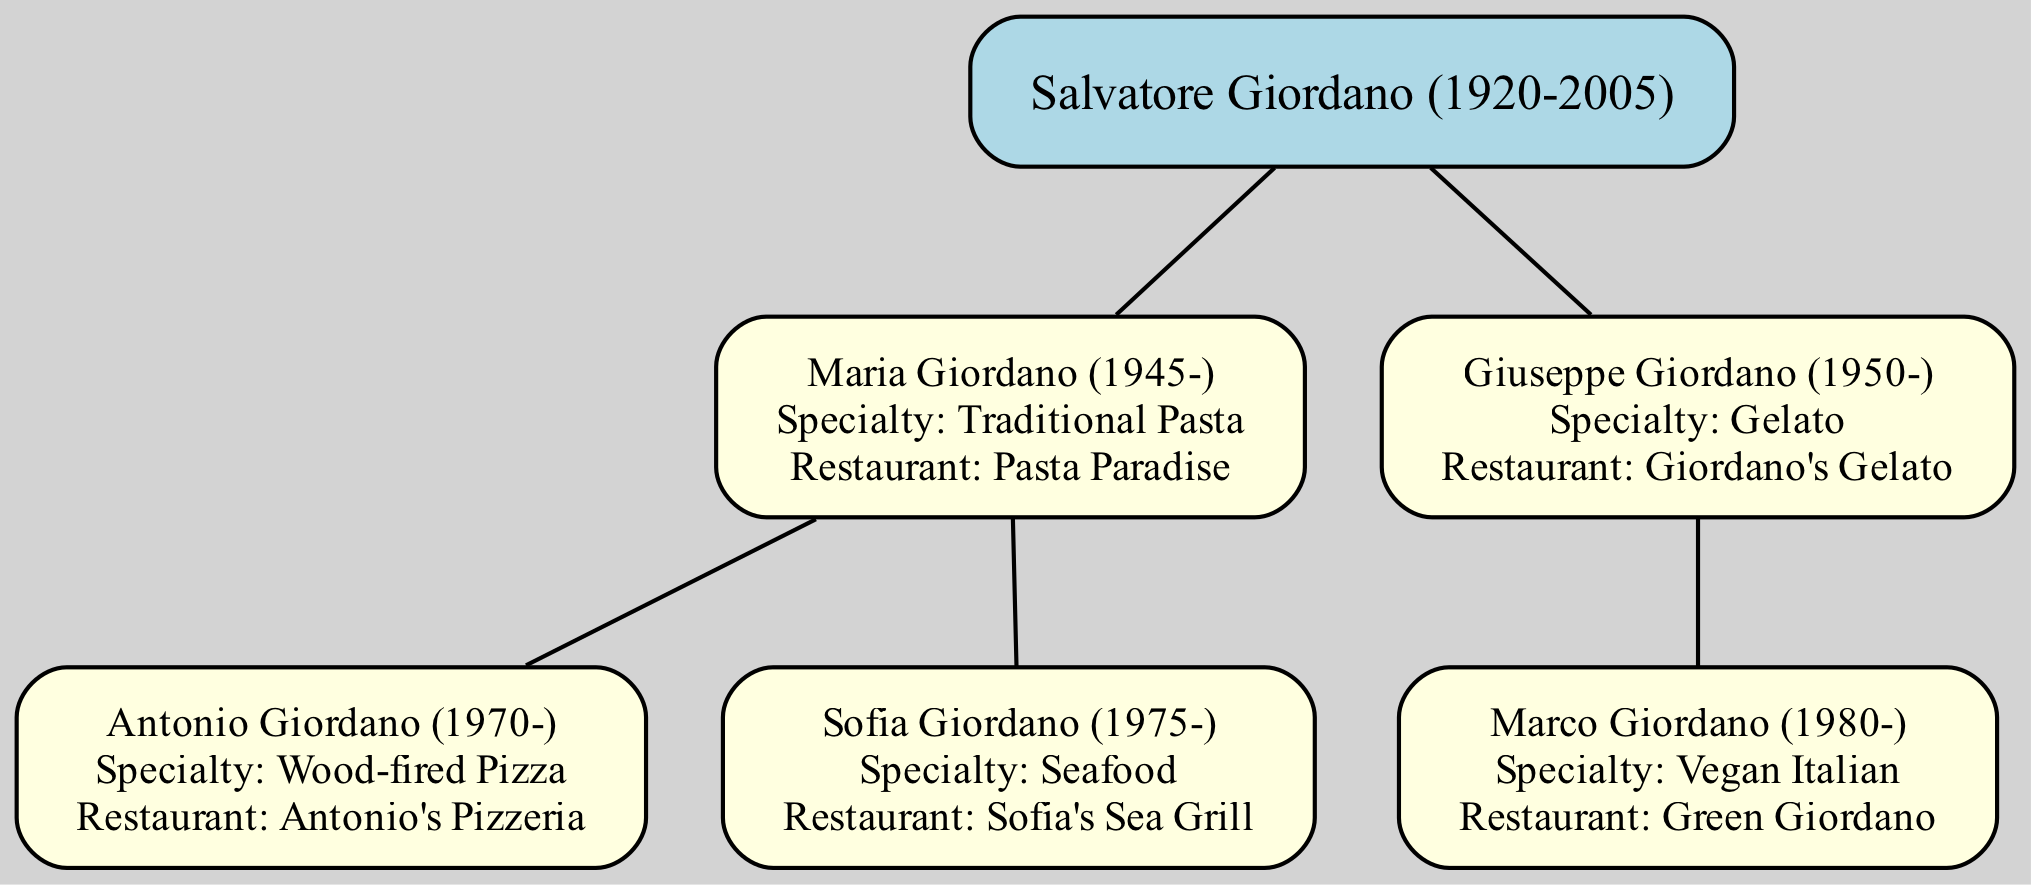What is the name of the root person in the family tree? The root person is Salvatore Giordano, who is the founding member of this family tree of restaurant owners.
Answer: Salvatore Giordano How many children does Maria Giordano have? Maria Giordano has two children: Antonio Giordano and Sofia Giordano, as indicated by her lineage in the diagram.
Answer: 2 What specialty is associated with Giuseppe Giordano? Giuseppe Giordano is known for his specialty in Gelato, which is explicitly stated in the diagram under his name.
Answer: Gelato Which restaurant does Sofia Giordano own? Sofia Giordano owns Sofia's Sea Grill, as specified next to her name in the diagram.
Answer: Sofia's Sea Grill Who is the only child of Giuseppe Giordano? The only child of Giuseppe Giordano is Marco Giordano, shown as the only descendant connected to him in the tree.
Answer: Marco Giordano What is the restaurant name of the person specialized in Vegan Italian cuisine? The person who specializes in Vegan Italian cuisine is Marco Giordano, and his restaurant is named Green Giordano, as depicted in the diagram.
Answer: Green Giordano Which culinary specialty is passed down from Salvatore Giordano to his daughter Maria? The specialty passed down from Salvatore Giordano to his daughter Maria is Traditional Pasta, which highlights the culinary tradition within the family.
Answer: Traditional Pasta How many total restaurants are mentioned in the family tree? There are a total of four restaurants mentioned in the family tree: Pasta Paradise, Antonio's Pizzeria, Sofia's Sea Grill, and Giordano's Gelato, along with Green Giordano.
Answer: 4 What is the relationship between Antonio Giordano and Sofia Giordano? Antonio Giordano and Sofia Giordano are siblings, as both are children of Maria Giordano according to the structure of the family tree.
Answer: Siblings 